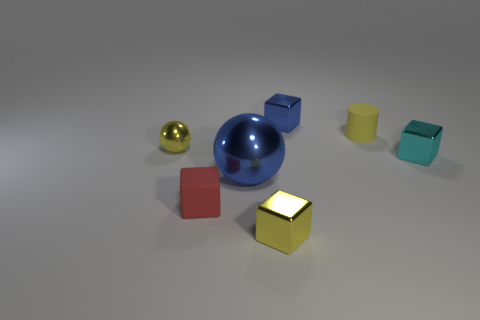Do the metallic object that is left of the tiny matte cube and the small rubber cylinder have the same color?
Your response must be concise. Yes. Is there a red cube on the left side of the yellow shiny object that is to the left of the large blue ball?
Make the answer very short. No. Are the ball on the right side of the red object and the cyan block made of the same material?
Provide a short and direct response. Yes. How many objects are both in front of the small metal ball and right of the large blue object?
Your response must be concise. 2. How many objects have the same material as the small red block?
Offer a terse response. 1. The large sphere that is made of the same material as the small cyan block is what color?
Your response must be concise. Blue. Is the number of big cylinders less than the number of small red matte blocks?
Provide a succinct answer. Yes. There is a yellow object behind the tiny metallic ball that is left of the metallic thing right of the yellow cylinder; what is its material?
Make the answer very short. Rubber. What is the small yellow block made of?
Keep it short and to the point. Metal. There is a sphere behind the big blue shiny sphere; does it have the same color as the rubber object that is right of the large blue shiny ball?
Offer a very short reply. Yes. 